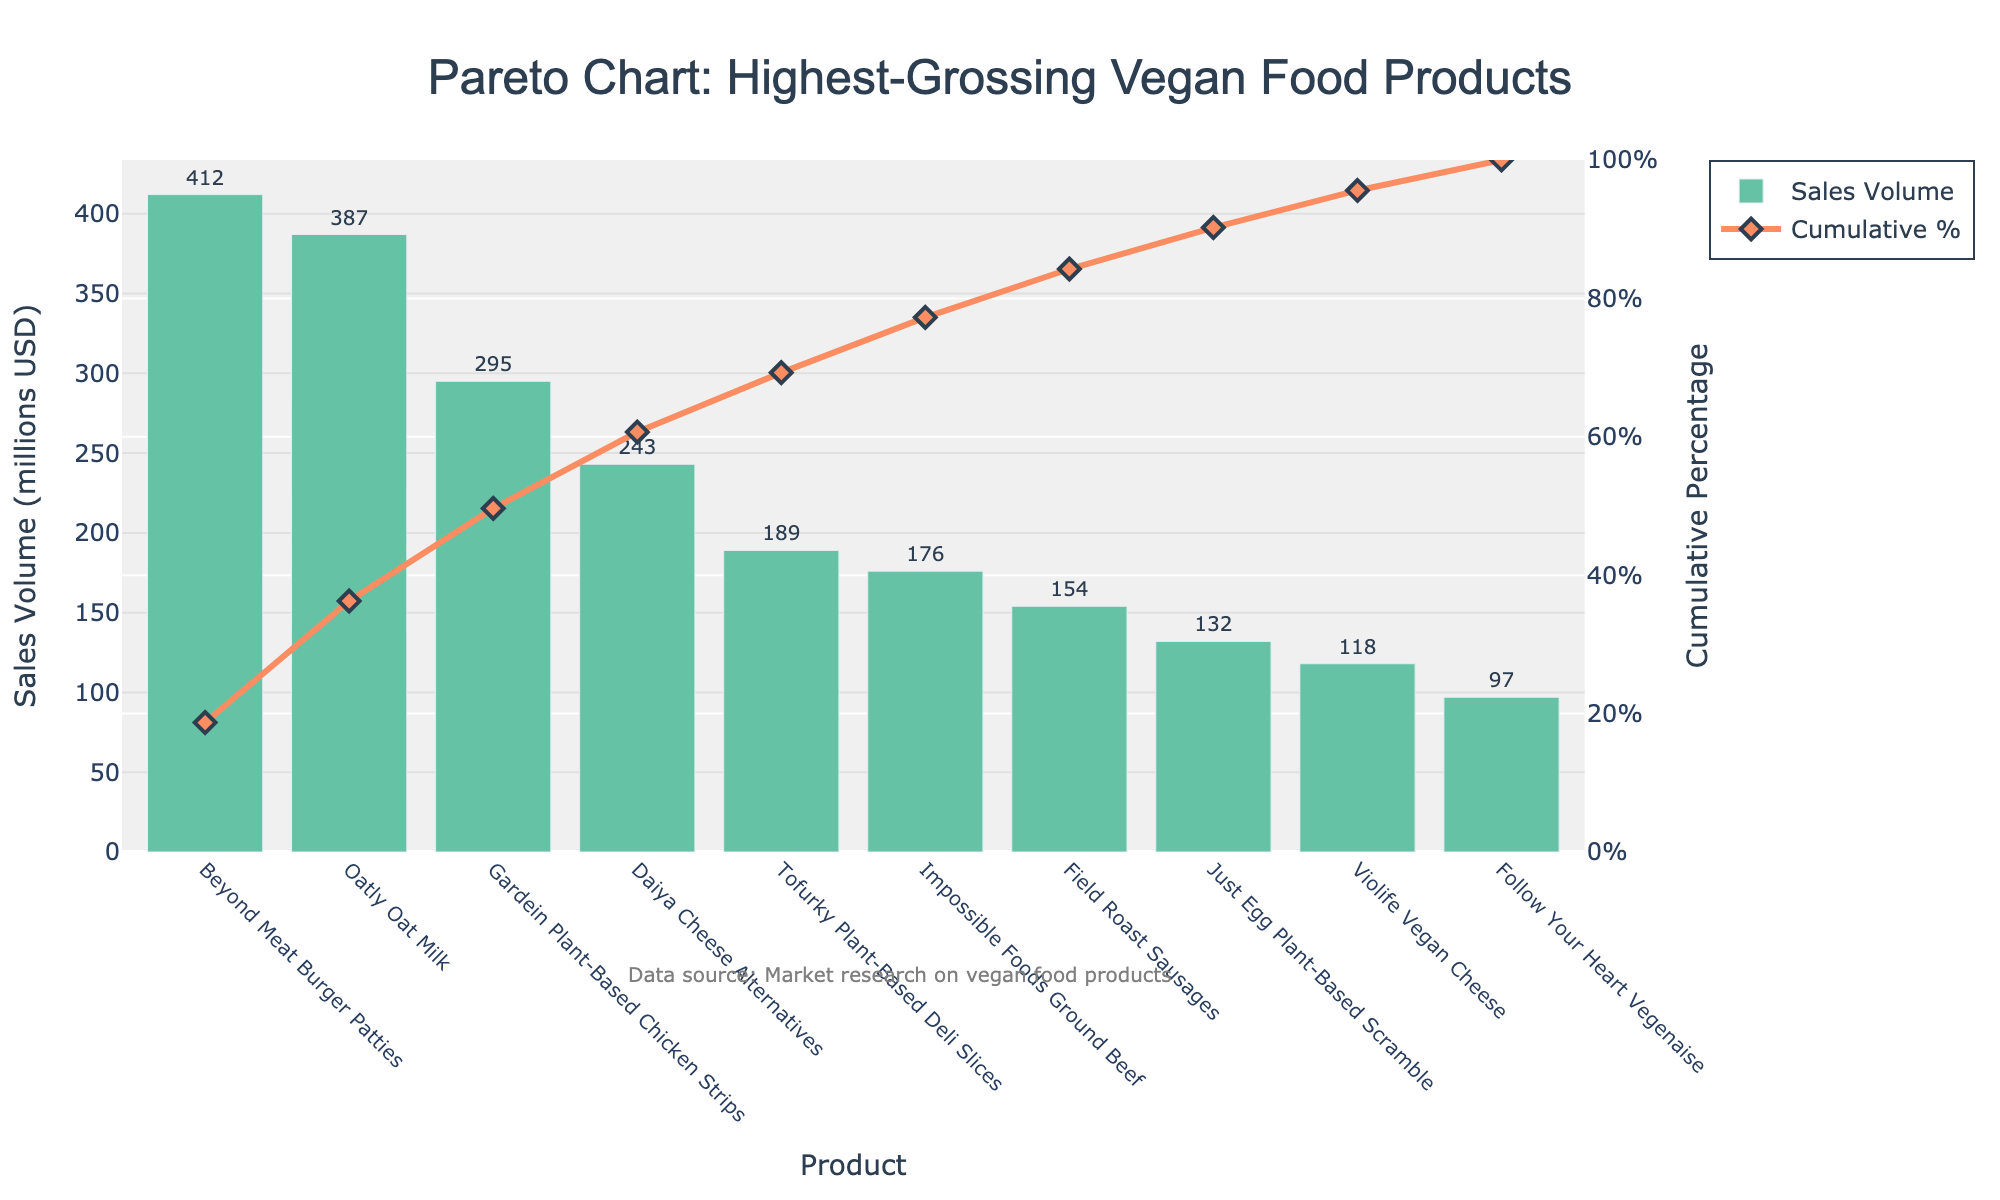What is the highest-grossing vegan food product according to the figure? Look at the bar chart and identify the tallest bar, which corresponds to the product with the highest sales volume.
Answer: Beyond Meat Burger Patties What is the cumulative percentage for Oatly Oat Milk? Find Oatly Oat Milk on the x-axis, then look at the secondary y-axis (right side) to find the cumulative percentage value represented by the line chart.
Answer: 41% How many products contribute to over 70% of total sales volume? Identify the point on the cumulative percentage line where it reaches or exceeds 70%, then count the number of products (bars) up to this point.
Answer: 5 products What is the sales volume difference between Beyond Meat Burger Patties and Tofurky Plant-Based Deli Slices? Subtract the sales volume of Tofurky Plant-Based Deli Slices from Beyond Meat Burger Patties: 412 - 189.
Answer: 223 million USD Which product has the lowest sales volume? Look at the bar chart and identify the shortest bar, which corresponds to the product with the lowest sales volume.
Answer: Follow Your Heart Vegenaise What percentage of the total sales volume is contributed by Daiya Cheese Alternatives and Impossible Foods Ground Beef combined? Sum the sales volumes of Daiya Cheese Alternatives and Impossible Foods Ground Beef, then divide by the total sales volume and multiply by 100: (243 + 176) / (Total Sales Volume) * 100.
Answer: 29% Is the cumulative percentage for the top three products more than 50%? Sum the cumulative percentages for the top three products (Beyond Meat Burger Patties, Oatly Oat Milk, Gardein Plant-Based Chicken Strips) and check if the total is more than 50%.
Answer: Yes Which product contributes the most to the cumulative percentage increase between the top two highest-grossing products and the third one? Compare the cumulative percentage increase from the top product to the second and from the second to the third. Identify the largest increase.
Answer: Oatly Oat Milk to Gardein Plant-Based Chicken Strips How many products have a sales volume of over 200 million USD? Count the number of bars (products) that exceed the 200 million USD mark on the primary y-axis (left side).
Answer: 4 products What is the cumulative sales volume for the top four products? Sum the sales volumes of the first four products listed in the figure: 412 + 387 + 295 + 243.
Answer: 1337 million USD 